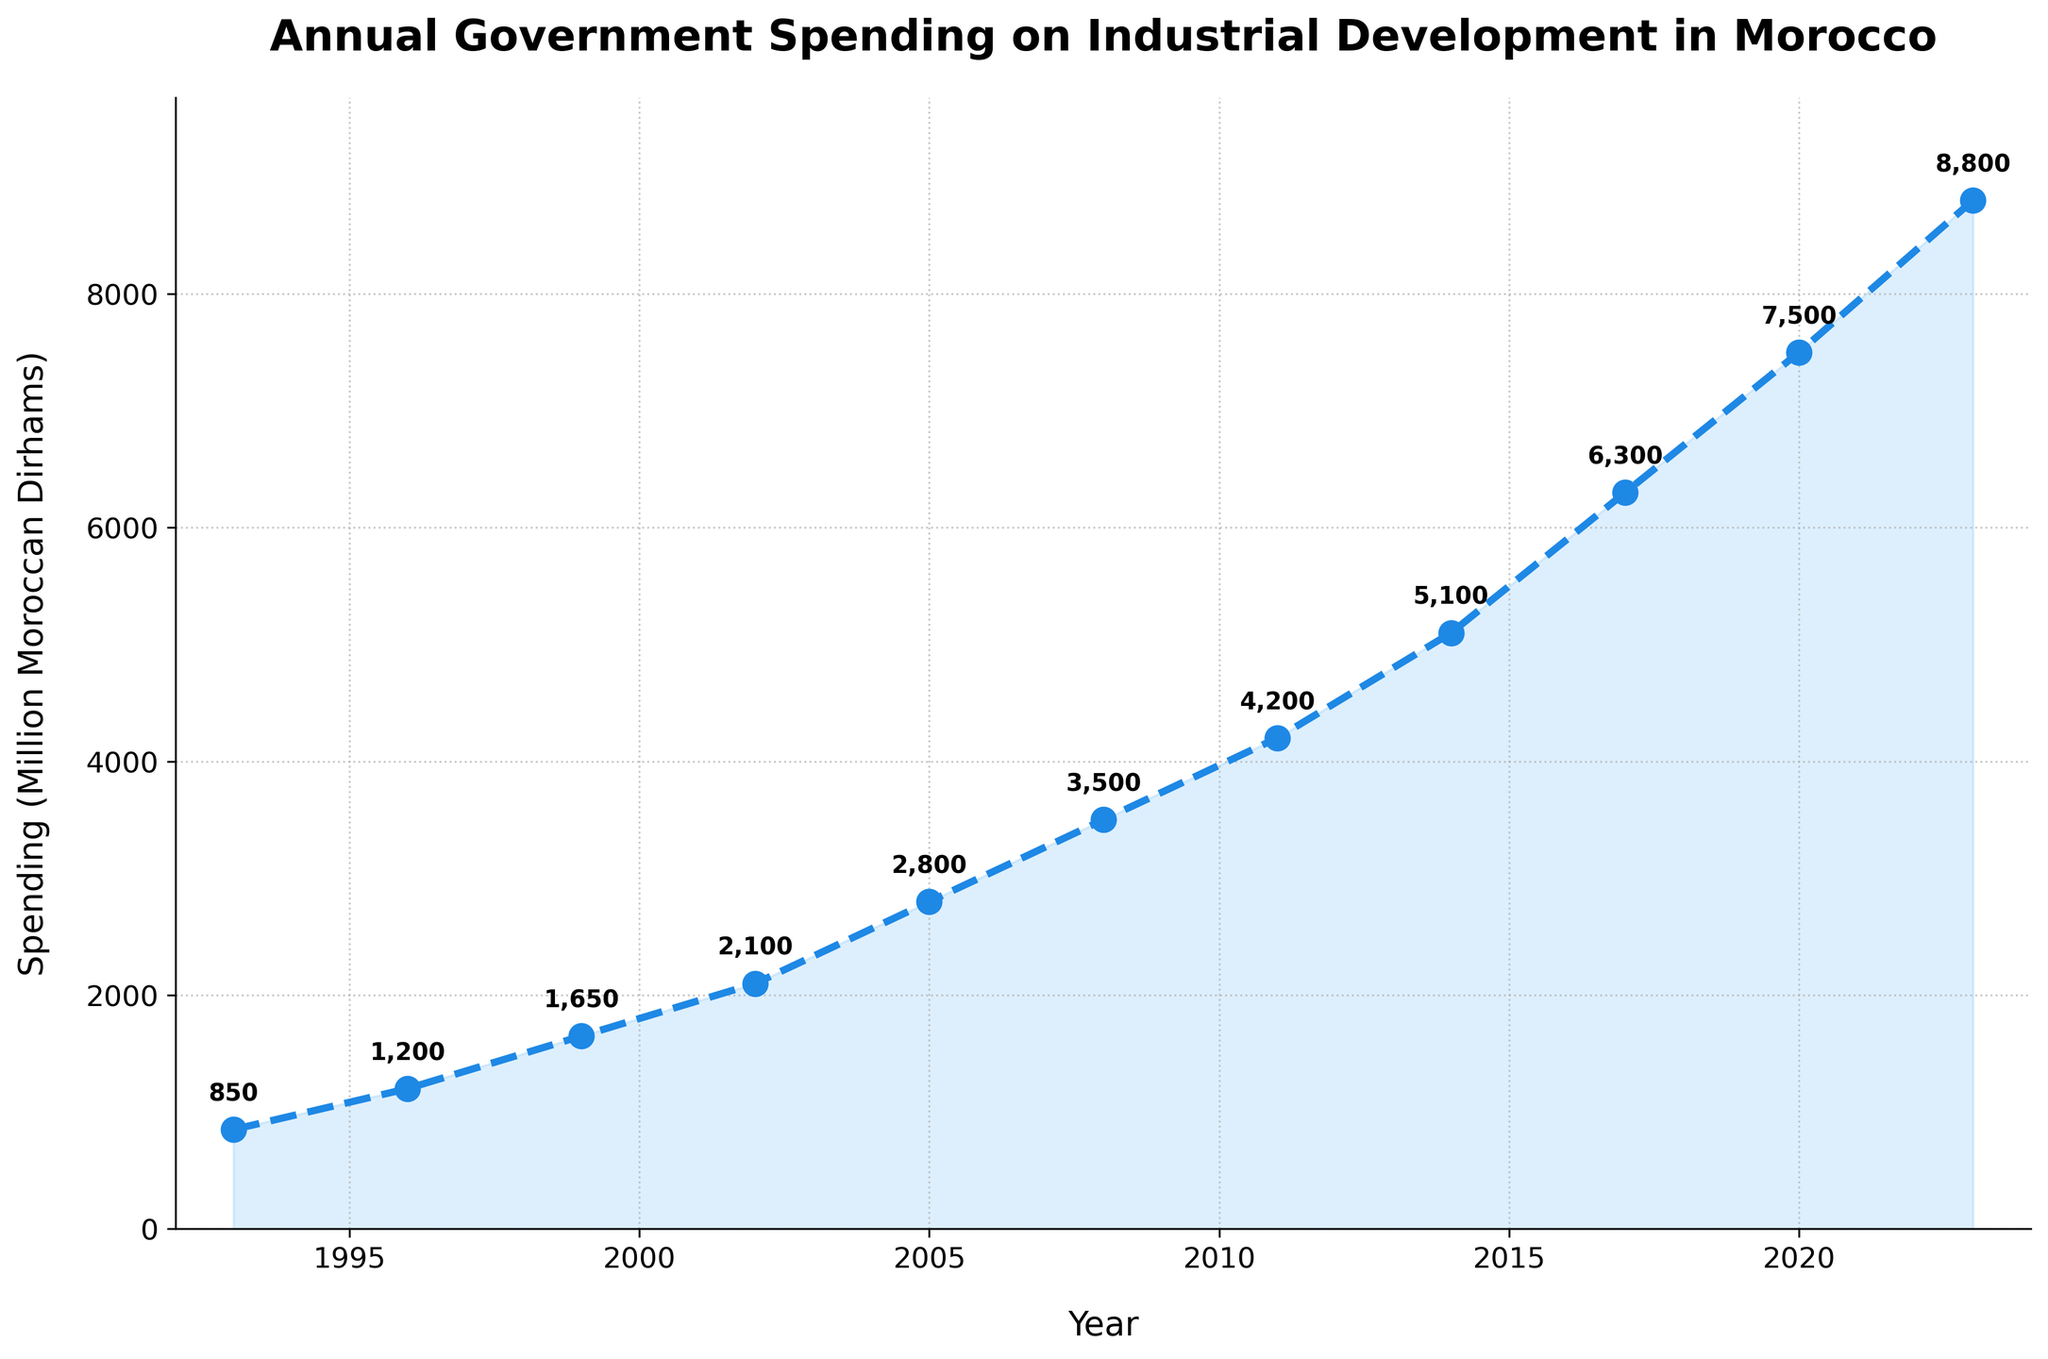What year did government spending on industrial development initiatives in Morocco exceed 5,000 million Moroccan Dirhams for the first time? The figure shows that spending exceeded 5,000 million Moroccan Dirhams in 2014.
Answer: 2014 Compare the government spending on industrial development initiatives in Morocco between 1993 and 2002. By how much did it increase? Government spending in 1993 was 850 million Moroccan Dirhams, and in 2002 it was 2,100 million Moroccan Dirhams. The difference is 2,100 - 850 = 1,250 million Moroccan Dirhams.
Answer: 1,250 million Moroccan Dirhams By what percentage did the government spending on industrial development initiatives increase from 2008 to 2023? The spending in 2008 was 3,500 million Moroccan Dirhams, and in 2023 it was 8,800 million Moroccan Dirhams. The percentage increase is calculated as ((8,800 - 3,500) / 3,500) * 100 ≈ 151.43%.
Answer: 151.43% Which period showed the highest increase in government spending on industrial development initiatives in Morocco, and what amount of increase was observed? The period between 2017 and 2020 showed the highest increase. The spending increased from 6,300 million Moroccan Dirhams to 7,500 million Moroccan Dirhams, an increase of 1,200 million Moroccan Dirhams.
Answer: 2017 to 2020, 1,200 million Moroccan Dirhams Identify the years when the government spending on industrial development initiatives increased by at least 1,000 million Moroccan Dirhams compared to the previous data point. The years are 1999 (increase of 450 million), 2002 (increase of 450 million), 2005 (increase of 700 million), 2008 (increase of 700 million), 2014 (increase of 900 million), 2017 (increase of 1,200 million), and 2020 (increase of 1,200 million).
Answer: 1999, 2002, 2005, 2008, 2014, 2017, 2020 Calculate the average annual spending on industrial development initiatives over the entire period shown in the figure. The sum of annual spendings is 850 + 1,200 + 1,650 + 2,100 + 2,800 + 3,500 + 4,200 + 5,100 + 6,300 + 7,500 + 8,800 = 43,000 million Moroccan Dirhams. There are 11 data points. So, the average annual spending is 43,000 / 11 ≈ 3,909 million Moroccan Dirhams.
Answer: 3,909 million Moroccan Dirhams 